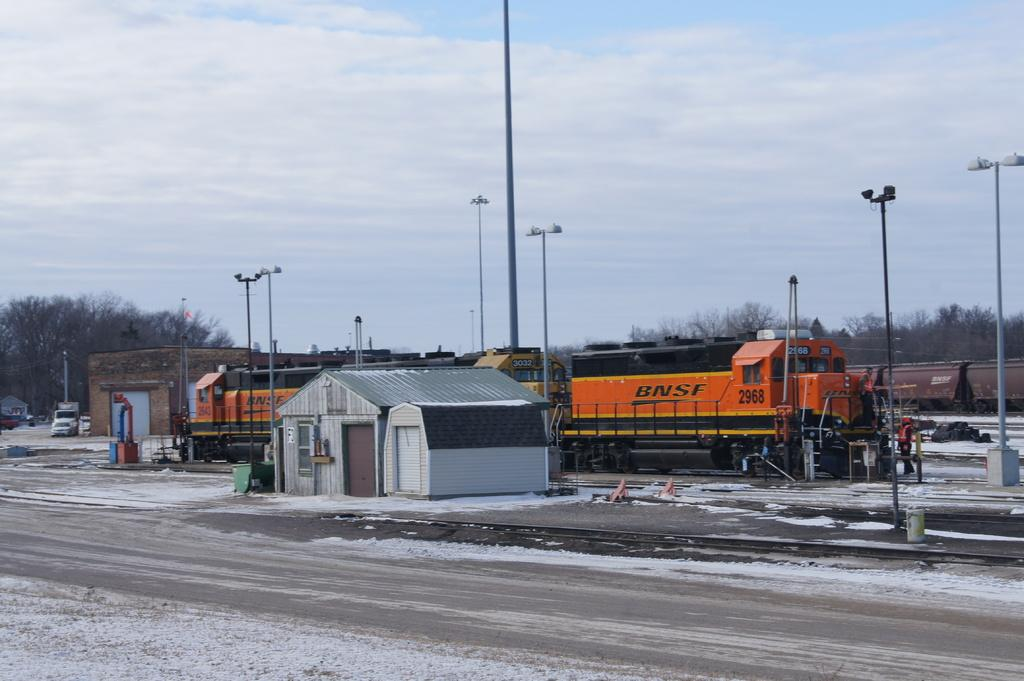<image>
Write a terse but informative summary of the picture. A road with snow and a train reading BNSF on the side. 